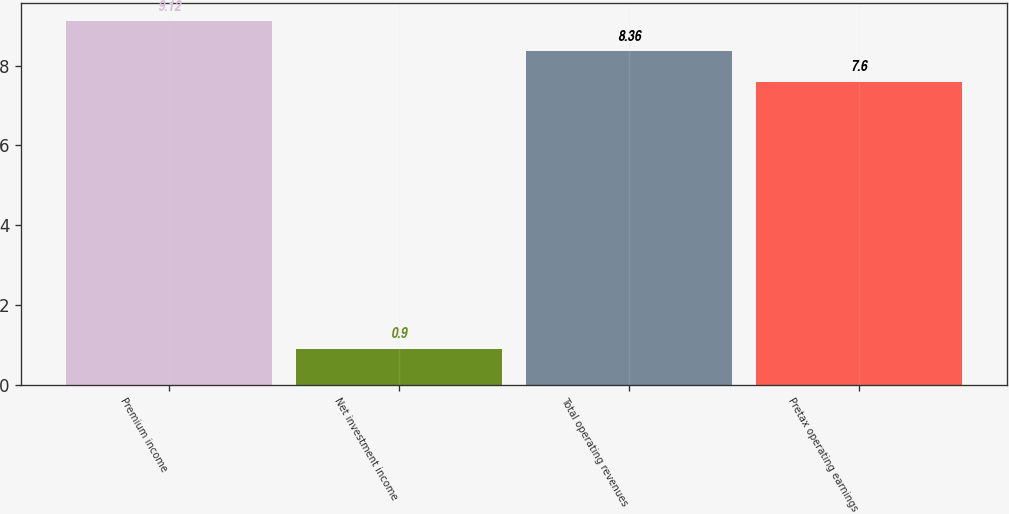<chart> <loc_0><loc_0><loc_500><loc_500><bar_chart><fcel>Premium income<fcel>Net investment income<fcel>Total operating revenues<fcel>Pretax operating earnings<nl><fcel>9.12<fcel>0.9<fcel>8.36<fcel>7.6<nl></chart> 